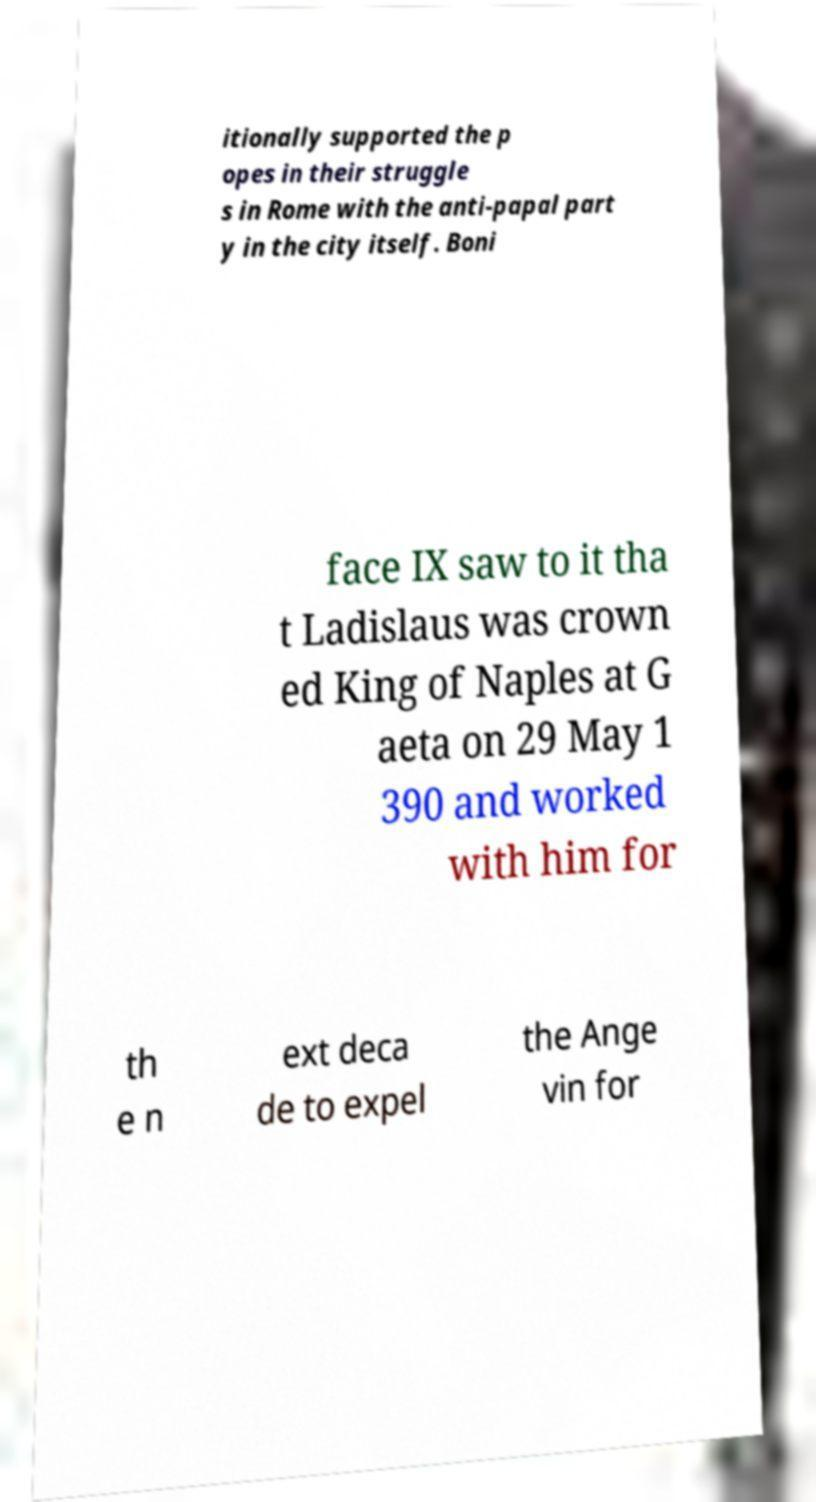Please read and relay the text visible in this image. What does it say? itionally supported the p opes in their struggle s in Rome with the anti-papal part y in the city itself. Boni face IX saw to it tha t Ladislaus was crown ed King of Naples at G aeta on 29 May 1 390 and worked with him for th e n ext deca de to expel the Ange vin for 